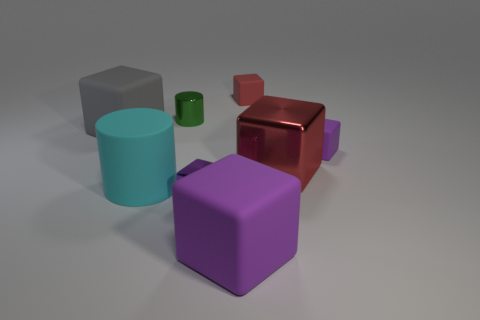Subtract all red cubes. How many cubes are left? 4 Subtract all cyan cylinders. How many purple cubes are left? 3 Subtract all gray blocks. How many blocks are left? 5 Subtract all blocks. How many objects are left? 2 Add 2 metal blocks. How many objects exist? 10 Subtract 2 cubes. How many cubes are left? 4 Add 1 cyan rubber things. How many cyan rubber things are left? 2 Add 2 yellow shiny cylinders. How many yellow shiny cylinders exist? 2 Subtract 1 gray cubes. How many objects are left? 7 Subtract all green cubes. Subtract all purple cylinders. How many cubes are left? 6 